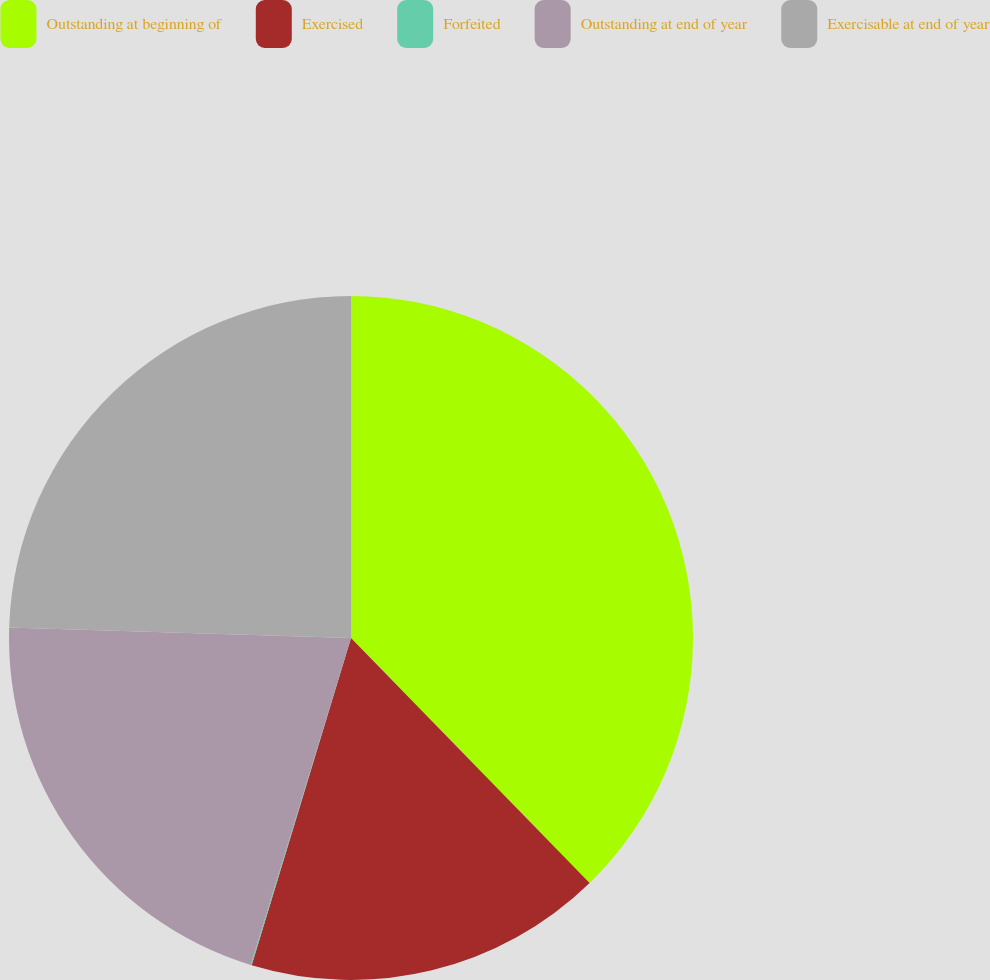<chart> <loc_0><loc_0><loc_500><loc_500><pie_chart><fcel>Outstanding at beginning of<fcel>Exercised<fcel>Forfeited<fcel>Outstanding at end of year<fcel>Exercisable at end of year<nl><fcel>37.71%<fcel>16.98%<fcel>0.05%<fcel>20.75%<fcel>24.51%<nl></chart> 